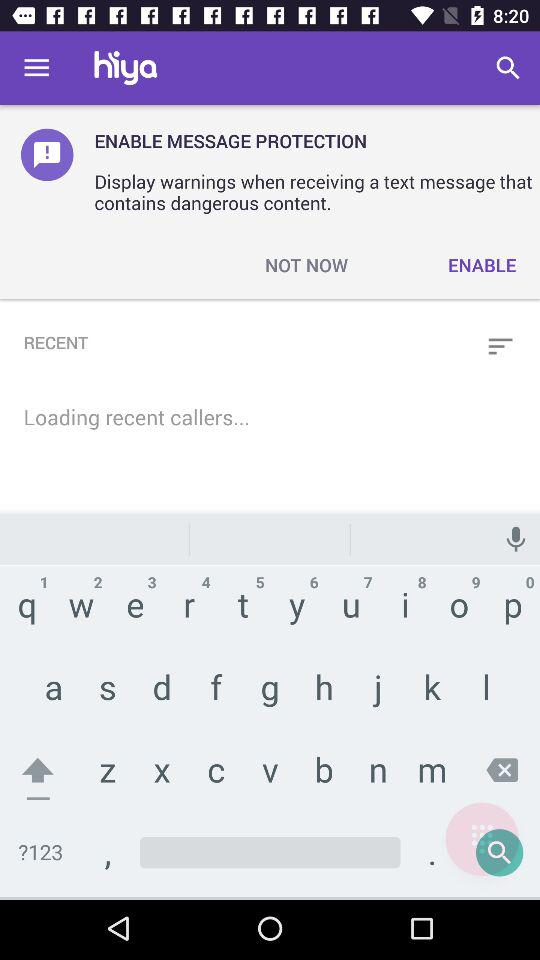What is the app name? The app name is "hiya". 